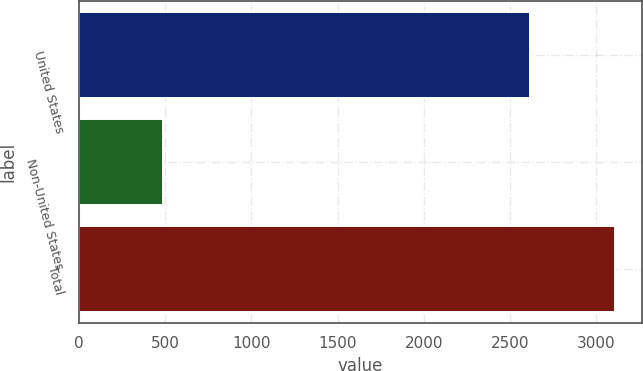Convert chart to OTSL. <chart><loc_0><loc_0><loc_500><loc_500><bar_chart><fcel>United States<fcel>Non-United States<fcel>Total<nl><fcel>2617.1<fcel>491<fcel>3108.1<nl></chart> 